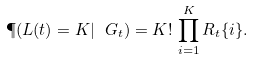<formula> <loc_0><loc_0><loc_500><loc_500>\P ( L ( t ) = K | \ G _ { t } ) = K ! \, \prod _ { i = 1 } ^ { K } R _ { t } \{ i \} .</formula> 